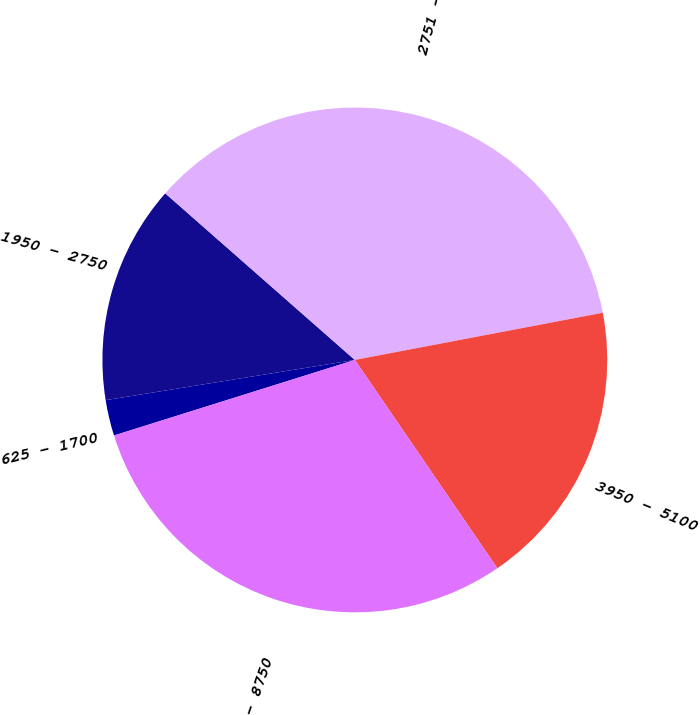<chart> <loc_0><loc_0><loc_500><loc_500><pie_chart><fcel>625 - 1700<fcel>1950 - 2750<fcel>2751 - 3750<fcel>3950 - 5100<fcel>6900 - 8750<nl><fcel>2.29%<fcel>14.02%<fcel>35.53%<fcel>18.44%<fcel>29.71%<nl></chart> 